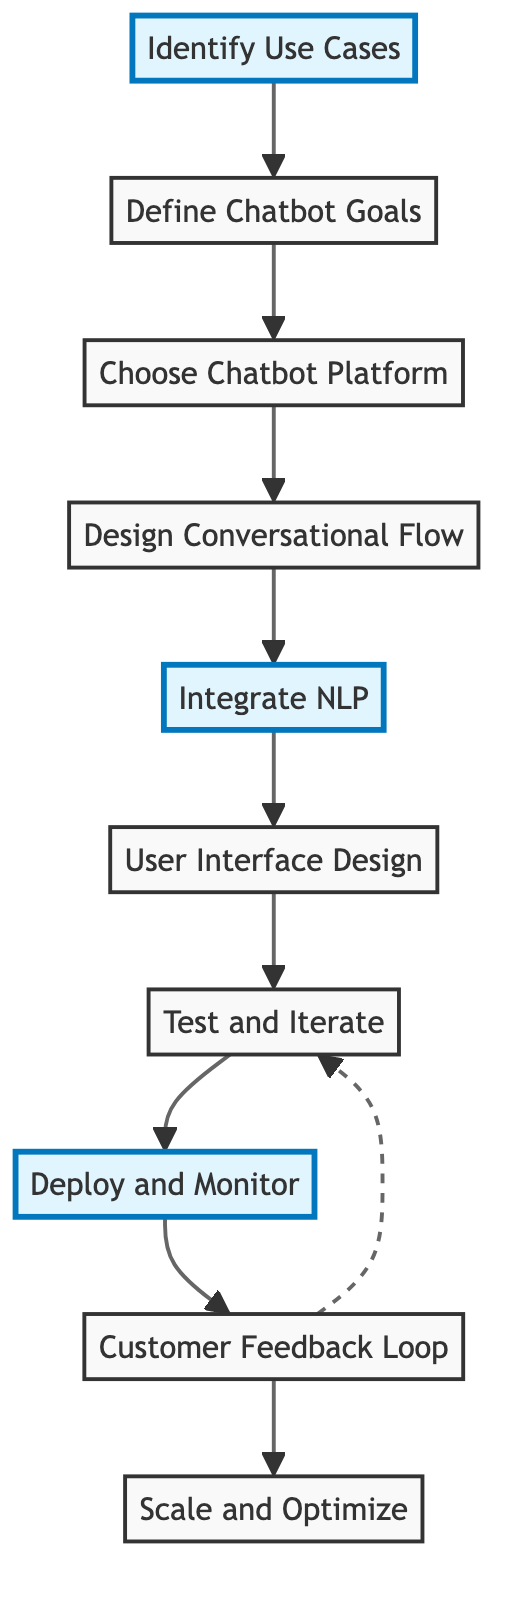What is the first step in the diagram? The first node in the flow chart is "Identify Use Cases," which indicates that the initial step involves pinpointing customer service scenarios for the chatbot.
Answer: Identify Use Cases How many total steps are in the process? By counting all the nodes in the flow chart, there are ten distinct steps involved in designing a user-friendly chatbot interface.
Answer: 10 What step follows "Define Chatbot Goals"? The diagram shows that after "Define Chatbot Goals," the next step is "Choose Chatbot Platform," indicating a sequential flow in the process.
Answer: Choose Chatbot Platform Which steps are highlighted in the diagram? The highlighted steps are "Identify Use Cases," "Integrate NLP," and "Deploy and Monitor," suggesting these are key focus areas in the chatbot design process.
Answer: Identify Use Cases, Integrate NLP, Deploy and Monitor What type of relationship exists between "Customer Feedback Loop" and "Test and Iterate"? The diagram indicates a dashed line from "Customer Feedback Loop" to "Test and Iterate," representing a feedback relationship that influences continuous improvements in the testing phase.
Answer: Feedback relationship How many steps are connected directly in the main flow? The diagram connects steps through direct lines, totaling nine direct connections, as there are ten nodes linked by single arrows in the main flow.
Answer: 9 Which node indicates the need for user feedback? The "Customer Feedback Loop" node specifically addresses establishing a mechanism for users to provide feedback on the chatbot's performance.
Answer: Customer Feedback Loop What is the final step in the flow chart? The last node shown in the flow chart is "Scale and Optimize," which concludes the process of designing a user-friendly chatbot interface with an emphasis on future growth and efficiency.
Answer: Scale and Optimize 